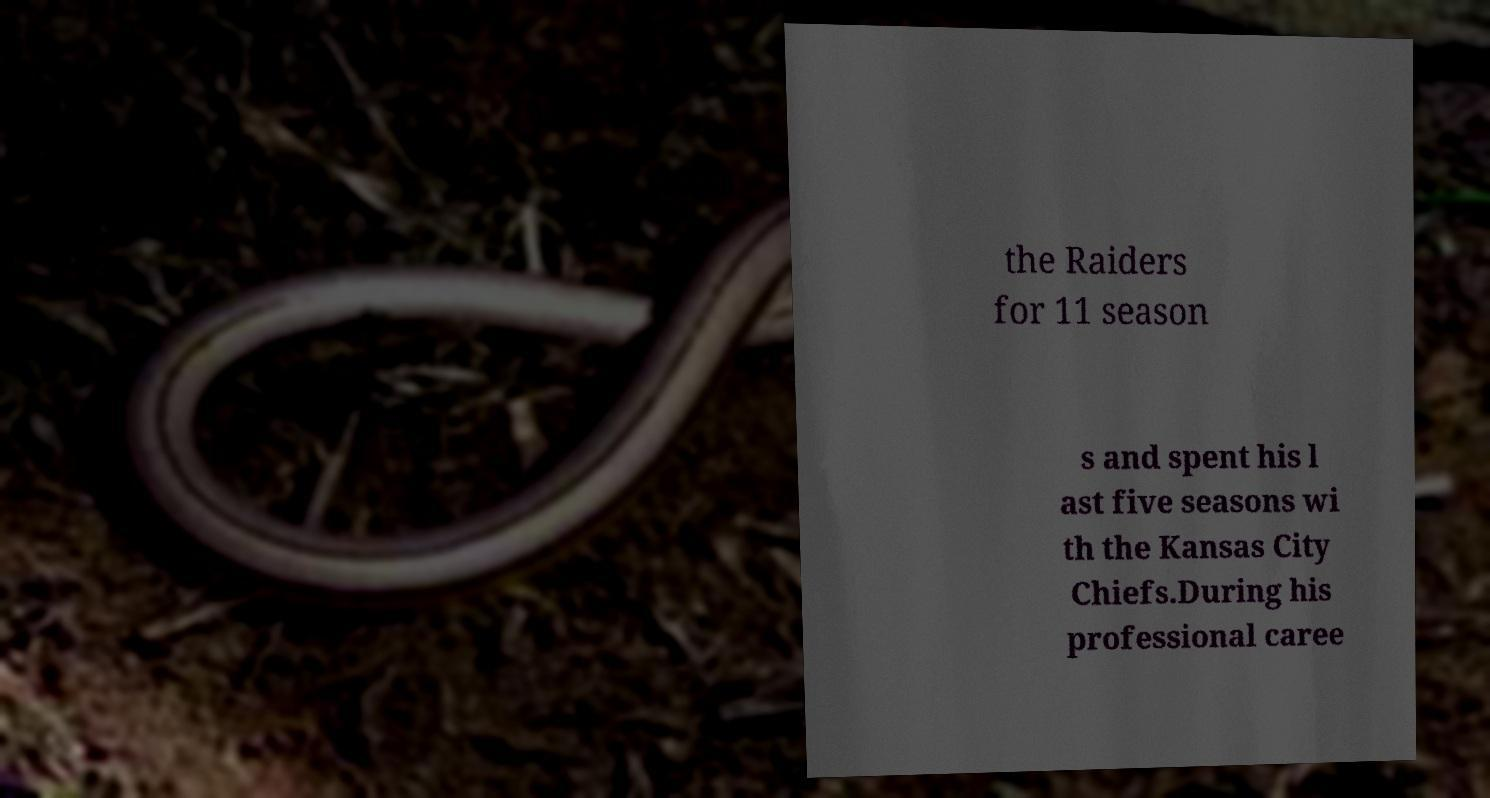Can you read and provide the text displayed in the image?This photo seems to have some interesting text. Can you extract and type it out for me? the Raiders for 11 season s and spent his l ast five seasons wi th the Kansas City Chiefs.During his professional caree 